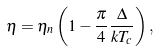Convert formula to latex. <formula><loc_0><loc_0><loc_500><loc_500>\eta = \eta _ { n } \left ( 1 - \frac { \pi } { 4 } \frac { \Delta } { k T _ { c } } \right ) ,</formula> 